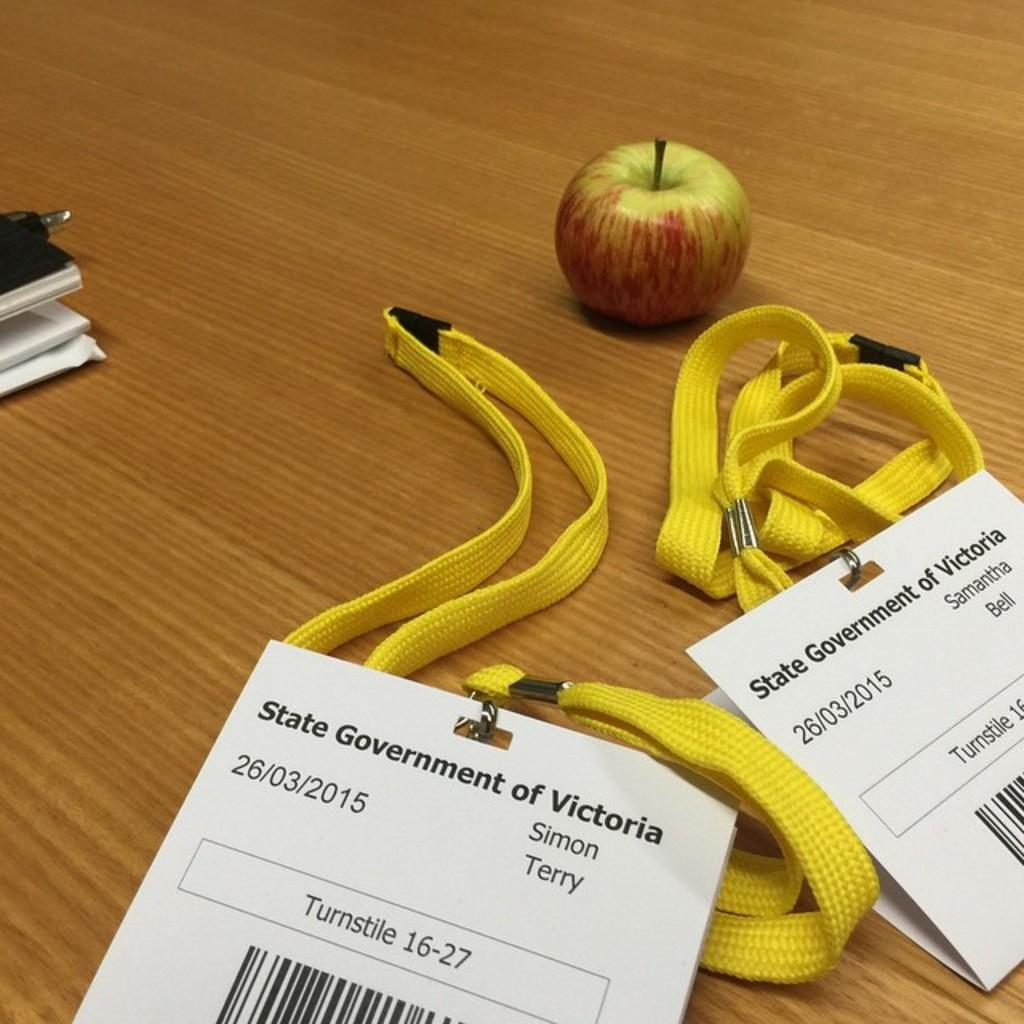What items can be seen on the table in the image? There are two ID cards, an apple, and a black object on the table. Can you describe the black object on the table? Unfortunately, the image does not provide enough detail to accurately describe the black object. What type of fruit is on the table? There is an apple on the table. How many suits are visible on the table in the image? There are no suits present in the image. What type of unit is being measured by the feet in the image? There are no feet or units being measured in the image. 